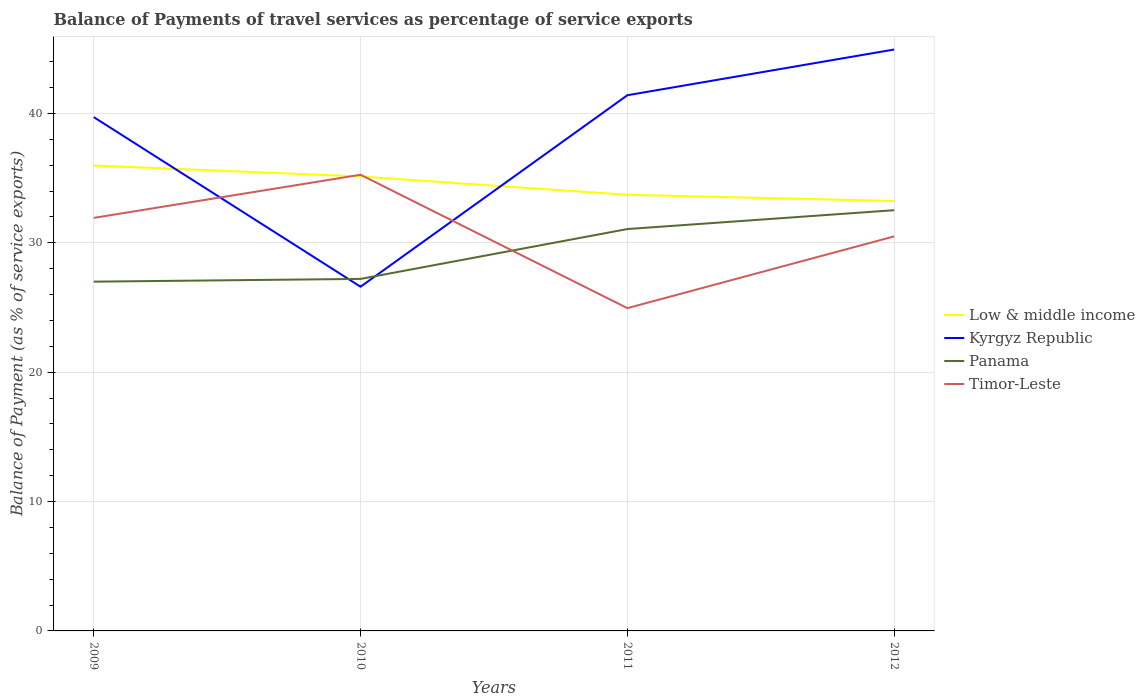Does the line corresponding to Timor-Leste intersect with the line corresponding to Panama?
Ensure brevity in your answer.  Yes. Is the number of lines equal to the number of legend labels?
Ensure brevity in your answer.  Yes. Across all years, what is the maximum balance of payments of travel services in Kyrgyz Republic?
Ensure brevity in your answer.  26.61. In which year was the balance of payments of travel services in Kyrgyz Republic maximum?
Make the answer very short. 2010. What is the total balance of payments of travel services in Panama in the graph?
Provide a short and direct response. -1.46. What is the difference between the highest and the second highest balance of payments of travel services in Timor-Leste?
Your answer should be compact. 10.31. What is the difference between the highest and the lowest balance of payments of travel services in Timor-Leste?
Your answer should be compact. 2. How many years are there in the graph?
Your response must be concise. 4. What is the difference between two consecutive major ticks on the Y-axis?
Your answer should be compact. 10. Does the graph contain any zero values?
Offer a terse response. No. Does the graph contain grids?
Offer a very short reply. Yes. Where does the legend appear in the graph?
Keep it short and to the point. Center right. How are the legend labels stacked?
Your answer should be very brief. Vertical. What is the title of the graph?
Ensure brevity in your answer.  Balance of Payments of travel services as percentage of service exports. What is the label or title of the X-axis?
Make the answer very short. Years. What is the label or title of the Y-axis?
Offer a terse response. Balance of Payment (as % of service exports). What is the Balance of Payment (as % of service exports) of Low & middle income in 2009?
Your answer should be compact. 35.98. What is the Balance of Payment (as % of service exports) in Kyrgyz Republic in 2009?
Ensure brevity in your answer.  39.72. What is the Balance of Payment (as % of service exports) in Panama in 2009?
Provide a short and direct response. 27. What is the Balance of Payment (as % of service exports) of Timor-Leste in 2009?
Provide a succinct answer. 31.93. What is the Balance of Payment (as % of service exports) of Low & middle income in 2010?
Offer a terse response. 35.13. What is the Balance of Payment (as % of service exports) in Kyrgyz Republic in 2010?
Make the answer very short. 26.61. What is the Balance of Payment (as % of service exports) in Panama in 2010?
Give a very brief answer. 27.21. What is the Balance of Payment (as % of service exports) in Timor-Leste in 2010?
Provide a succinct answer. 35.26. What is the Balance of Payment (as % of service exports) in Low & middle income in 2011?
Offer a very short reply. 33.71. What is the Balance of Payment (as % of service exports) in Kyrgyz Republic in 2011?
Provide a succinct answer. 41.41. What is the Balance of Payment (as % of service exports) in Panama in 2011?
Your answer should be compact. 31.06. What is the Balance of Payment (as % of service exports) in Timor-Leste in 2011?
Make the answer very short. 24.95. What is the Balance of Payment (as % of service exports) of Low & middle income in 2012?
Your response must be concise. 33.23. What is the Balance of Payment (as % of service exports) of Kyrgyz Republic in 2012?
Offer a very short reply. 44.94. What is the Balance of Payment (as % of service exports) in Panama in 2012?
Your answer should be very brief. 32.52. What is the Balance of Payment (as % of service exports) in Timor-Leste in 2012?
Your answer should be compact. 30.5. Across all years, what is the maximum Balance of Payment (as % of service exports) of Low & middle income?
Your answer should be compact. 35.98. Across all years, what is the maximum Balance of Payment (as % of service exports) of Kyrgyz Republic?
Make the answer very short. 44.94. Across all years, what is the maximum Balance of Payment (as % of service exports) in Panama?
Make the answer very short. 32.52. Across all years, what is the maximum Balance of Payment (as % of service exports) in Timor-Leste?
Provide a short and direct response. 35.26. Across all years, what is the minimum Balance of Payment (as % of service exports) in Low & middle income?
Give a very brief answer. 33.23. Across all years, what is the minimum Balance of Payment (as % of service exports) in Kyrgyz Republic?
Your response must be concise. 26.61. Across all years, what is the minimum Balance of Payment (as % of service exports) in Panama?
Keep it short and to the point. 27. Across all years, what is the minimum Balance of Payment (as % of service exports) in Timor-Leste?
Ensure brevity in your answer.  24.95. What is the total Balance of Payment (as % of service exports) in Low & middle income in the graph?
Your answer should be compact. 138.06. What is the total Balance of Payment (as % of service exports) of Kyrgyz Republic in the graph?
Keep it short and to the point. 152.68. What is the total Balance of Payment (as % of service exports) in Panama in the graph?
Give a very brief answer. 117.8. What is the total Balance of Payment (as % of service exports) of Timor-Leste in the graph?
Provide a succinct answer. 122.64. What is the difference between the Balance of Payment (as % of service exports) in Low & middle income in 2009 and that in 2010?
Ensure brevity in your answer.  0.85. What is the difference between the Balance of Payment (as % of service exports) in Kyrgyz Republic in 2009 and that in 2010?
Make the answer very short. 13.11. What is the difference between the Balance of Payment (as % of service exports) of Panama in 2009 and that in 2010?
Offer a very short reply. -0.21. What is the difference between the Balance of Payment (as % of service exports) in Timor-Leste in 2009 and that in 2010?
Make the answer very short. -3.33. What is the difference between the Balance of Payment (as % of service exports) in Low & middle income in 2009 and that in 2011?
Offer a terse response. 2.27. What is the difference between the Balance of Payment (as % of service exports) in Kyrgyz Republic in 2009 and that in 2011?
Provide a succinct answer. -1.69. What is the difference between the Balance of Payment (as % of service exports) of Panama in 2009 and that in 2011?
Offer a very short reply. -4.07. What is the difference between the Balance of Payment (as % of service exports) in Timor-Leste in 2009 and that in 2011?
Your answer should be very brief. 6.98. What is the difference between the Balance of Payment (as % of service exports) in Low & middle income in 2009 and that in 2012?
Give a very brief answer. 2.74. What is the difference between the Balance of Payment (as % of service exports) of Kyrgyz Republic in 2009 and that in 2012?
Your answer should be compact. -5.23. What is the difference between the Balance of Payment (as % of service exports) in Panama in 2009 and that in 2012?
Offer a very short reply. -5.52. What is the difference between the Balance of Payment (as % of service exports) in Timor-Leste in 2009 and that in 2012?
Your answer should be compact. 1.43. What is the difference between the Balance of Payment (as % of service exports) of Low & middle income in 2010 and that in 2011?
Offer a very short reply. 1.42. What is the difference between the Balance of Payment (as % of service exports) of Kyrgyz Republic in 2010 and that in 2011?
Provide a short and direct response. -14.8. What is the difference between the Balance of Payment (as % of service exports) in Panama in 2010 and that in 2011?
Make the answer very short. -3.85. What is the difference between the Balance of Payment (as % of service exports) in Timor-Leste in 2010 and that in 2011?
Your answer should be compact. 10.31. What is the difference between the Balance of Payment (as % of service exports) in Low & middle income in 2010 and that in 2012?
Offer a terse response. 1.9. What is the difference between the Balance of Payment (as % of service exports) in Kyrgyz Republic in 2010 and that in 2012?
Keep it short and to the point. -18.34. What is the difference between the Balance of Payment (as % of service exports) of Panama in 2010 and that in 2012?
Offer a terse response. -5.31. What is the difference between the Balance of Payment (as % of service exports) of Timor-Leste in 2010 and that in 2012?
Your answer should be compact. 4.76. What is the difference between the Balance of Payment (as % of service exports) in Low & middle income in 2011 and that in 2012?
Your answer should be very brief. 0.48. What is the difference between the Balance of Payment (as % of service exports) in Kyrgyz Republic in 2011 and that in 2012?
Ensure brevity in your answer.  -3.53. What is the difference between the Balance of Payment (as % of service exports) of Panama in 2011 and that in 2012?
Offer a terse response. -1.46. What is the difference between the Balance of Payment (as % of service exports) in Timor-Leste in 2011 and that in 2012?
Offer a very short reply. -5.55. What is the difference between the Balance of Payment (as % of service exports) of Low & middle income in 2009 and the Balance of Payment (as % of service exports) of Kyrgyz Republic in 2010?
Ensure brevity in your answer.  9.37. What is the difference between the Balance of Payment (as % of service exports) of Low & middle income in 2009 and the Balance of Payment (as % of service exports) of Panama in 2010?
Make the answer very short. 8.77. What is the difference between the Balance of Payment (as % of service exports) of Low & middle income in 2009 and the Balance of Payment (as % of service exports) of Timor-Leste in 2010?
Offer a very short reply. 0.72. What is the difference between the Balance of Payment (as % of service exports) of Kyrgyz Republic in 2009 and the Balance of Payment (as % of service exports) of Panama in 2010?
Ensure brevity in your answer.  12.51. What is the difference between the Balance of Payment (as % of service exports) in Kyrgyz Republic in 2009 and the Balance of Payment (as % of service exports) in Timor-Leste in 2010?
Ensure brevity in your answer.  4.46. What is the difference between the Balance of Payment (as % of service exports) of Panama in 2009 and the Balance of Payment (as % of service exports) of Timor-Leste in 2010?
Give a very brief answer. -8.26. What is the difference between the Balance of Payment (as % of service exports) of Low & middle income in 2009 and the Balance of Payment (as % of service exports) of Kyrgyz Republic in 2011?
Your response must be concise. -5.43. What is the difference between the Balance of Payment (as % of service exports) in Low & middle income in 2009 and the Balance of Payment (as % of service exports) in Panama in 2011?
Ensure brevity in your answer.  4.91. What is the difference between the Balance of Payment (as % of service exports) of Low & middle income in 2009 and the Balance of Payment (as % of service exports) of Timor-Leste in 2011?
Provide a short and direct response. 11.03. What is the difference between the Balance of Payment (as % of service exports) in Kyrgyz Republic in 2009 and the Balance of Payment (as % of service exports) in Panama in 2011?
Give a very brief answer. 8.65. What is the difference between the Balance of Payment (as % of service exports) of Kyrgyz Republic in 2009 and the Balance of Payment (as % of service exports) of Timor-Leste in 2011?
Your response must be concise. 14.77. What is the difference between the Balance of Payment (as % of service exports) in Panama in 2009 and the Balance of Payment (as % of service exports) in Timor-Leste in 2011?
Offer a very short reply. 2.05. What is the difference between the Balance of Payment (as % of service exports) in Low & middle income in 2009 and the Balance of Payment (as % of service exports) in Kyrgyz Republic in 2012?
Your answer should be compact. -8.97. What is the difference between the Balance of Payment (as % of service exports) of Low & middle income in 2009 and the Balance of Payment (as % of service exports) of Panama in 2012?
Give a very brief answer. 3.46. What is the difference between the Balance of Payment (as % of service exports) of Low & middle income in 2009 and the Balance of Payment (as % of service exports) of Timor-Leste in 2012?
Make the answer very short. 5.48. What is the difference between the Balance of Payment (as % of service exports) of Kyrgyz Republic in 2009 and the Balance of Payment (as % of service exports) of Panama in 2012?
Your answer should be very brief. 7.19. What is the difference between the Balance of Payment (as % of service exports) in Kyrgyz Republic in 2009 and the Balance of Payment (as % of service exports) in Timor-Leste in 2012?
Offer a very short reply. 9.22. What is the difference between the Balance of Payment (as % of service exports) in Panama in 2009 and the Balance of Payment (as % of service exports) in Timor-Leste in 2012?
Your answer should be compact. -3.5. What is the difference between the Balance of Payment (as % of service exports) in Low & middle income in 2010 and the Balance of Payment (as % of service exports) in Kyrgyz Republic in 2011?
Keep it short and to the point. -6.28. What is the difference between the Balance of Payment (as % of service exports) in Low & middle income in 2010 and the Balance of Payment (as % of service exports) in Panama in 2011?
Keep it short and to the point. 4.07. What is the difference between the Balance of Payment (as % of service exports) in Low & middle income in 2010 and the Balance of Payment (as % of service exports) in Timor-Leste in 2011?
Ensure brevity in your answer.  10.18. What is the difference between the Balance of Payment (as % of service exports) of Kyrgyz Republic in 2010 and the Balance of Payment (as % of service exports) of Panama in 2011?
Your answer should be very brief. -4.46. What is the difference between the Balance of Payment (as % of service exports) in Kyrgyz Republic in 2010 and the Balance of Payment (as % of service exports) in Timor-Leste in 2011?
Offer a very short reply. 1.66. What is the difference between the Balance of Payment (as % of service exports) in Panama in 2010 and the Balance of Payment (as % of service exports) in Timor-Leste in 2011?
Make the answer very short. 2.26. What is the difference between the Balance of Payment (as % of service exports) of Low & middle income in 2010 and the Balance of Payment (as % of service exports) of Kyrgyz Republic in 2012?
Your answer should be very brief. -9.81. What is the difference between the Balance of Payment (as % of service exports) in Low & middle income in 2010 and the Balance of Payment (as % of service exports) in Panama in 2012?
Your answer should be compact. 2.61. What is the difference between the Balance of Payment (as % of service exports) of Low & middle income in 2010 and the Balance of Payment (as % of service exports) of Timor-Leste in 2012?
Provide a short and direct response. 4.63. What is the difference between the Balance of Payment (as % of service exports) of Kyrgyz Republic in 2010 and the Balance of Payment (as % of service exports) of Panama in 2012?
Your answer should be very brief. -5.92. What is the difference between the Balance of Payment (as % of service exports) in Kyrgyz Republic in 2010 and the Balance of Payment (as % of service exports) in Timor-Leste in 2012?
Keep it short and to the point. -3.89. What is the difference between the Balance of Payment (as % of service exports) of Panama in 2010 and the Balance of Payment (as % of service exports) of Timor-Leste in 2012?
Your response must be concise. -3.29. What is the difference between the Balance of Payment (as % of service exports) of Low & middle income in 2011 and the Balance of Payment (as % of service exports) of Kyrgyz Republic in 2012?
Offer a very short reply. -11.23. What is the difference between the Balance of Payment (as % of service exports) in Low & middle income in 2011 and the Balance of Payment (as % of service exports) in Panama in 2012?
Your response must be concise. 1.19. What is the difference between the Balance of Payment (as % of service exports) in Low & middle income in 2011 and the Balance of Payment (as % of service exports) in Timor-Leste in 2012?
Your response must be concise. 3.21. What is the difference between the Balance of Payment (as % of service exports) in Kyrgyz Republic in 2011 and the Balance of Payment (as % of service exports) in Panama in 2012?
Your response must be concise. 8.89. What is the difference between the Balance of Payment (as % of service exports) in Kyrgyz Republic in 2011 and the Balance of Payment (as % of service exports) in Timor-Leste in 2012?
Provide a short and direct response. 10.91. What is the difference between the Balance of Payment (as % of service exports) of Panama in 2011 and the Balance of Payment (as % of service exports) of Timor-Leste in 2012?
Give a very brief answer. 0.57. What is the average Balance of Payment (as % of service exports) of Low & middle income per year?
Your answer should be compact. 34.51. What is the average Balance of Payment (as % of service exports) of Kyrgyz Republic per year?
Provide a short and direct response. 38.17. What is the average Balance of Payment (as % of service exports) in Panama per year?
Provide a short and direct response. 29.45. What is the average Balance of Payment (as % of service exports) in Timor-Leste per year?
Provide a short and direct response. 30.66. In the year 2009, what is the difference between the Balance of Payment (as % of service exports) of Low & middle income and Balance of Payment (as % of service exports) of Kyrgyz Republic?
Provide a succinct answer. -3.74. In the year 2009, what is the difference between the Balance of Payment (as % of service exports) of Low & middle income and Balance of Payment (as % of service exports) of Panama?
Offer a very short reply. 8.98. In the year 2009, what is the difference between the Balance of Payment (as % of service exports) in Low & middle income and Balance of Payment (as % of service exports) in Timor-Leste?
Offer a very short reply. 4.05. In the year 2009, what is the difference between the Balance of Payment (as % of service exports) of Kyrgyz Republic and Balance of Payment (as % of service exports) of Panama?
Provide a succinct answer. 12.72. In the year 2009, what is the difference between the Balance of Payment (as % of service exports) in Kyrgyz Republic and Balance of Payment (as % of service exports) in Timor-Leste?
Give a very brief answer. 7.79. In the year 2009, what is the difference between the Balance of Payment (as % of service exports) of Panama and Balance of Payment (as % of service exports) of Timor-Leste?
Your answer should be very brief. -4.93. In the year 2010, what is the difference between the Balance of Payment (as % of service exports) in Low & middle income and Balance of Payment (as % of service exports) in Kyrgyz Republic?
Your answer should be very brief. 8.52. In the year 2010, what is the difference between the Balance of Payment (as % of service exports) of Low & middle income and Balance of Payment (as % of service exports) of Panama?
Your answer should be compact. 7.92. In the year 2010, what is the difference between the Balance of Payment (as % of service exports) in Low & middle income and Balance of Payment (as % of service exports) in Timor-Leste?
Provide a succinct answer. -0.13. In the year 2010, what is the difference between the Balance of Payment (as % of service exports) in Kyrgyz Republic and Balance of Payment (as % of service exports) in Panama?
Offer a very short reply. -0.6. In the year 2010, what is the difference between the Balance of Payment (as % of service exports) in Kyrgyz Republic and Balance of Payment (as % of service exports) in Timor-Leste?
Your response must be concise. -8.65. In the year 2010, what is the difference between the Balance of Payment (as % of service exports) in Panama and Balance of Payment (as % of service exports) in Timor-Leste?
Give a very brief answer. -8.05. In the year 2011, what is the difference between the Balance of Payment (as % of service exports) in Low & middle income and Balance of Payment (as % of service exports) in Kyrgyz Republic?
Ensure brevity in your answer.  -7.7. In the year 2011, what is the difference between the Balance of Payment (as % of service exports) in Low & middle income and Balance of Payment (as % of service exports) in Panama?
Ensure brevity in your answer.  2.65. In the year 2011, what is the difference between the Balance of Payment (as % of service exports) in Low & middle income and Balance of Payment (as % of service exports) in Timor-Leste?
Make the answer very short. 8.76. In the year 2011, what is the difference between the Balance of Payment (as % of service exports) in Kyrgyz Republic and Balance of Payment (as % of service exports) in Panama?
Ensure brevity in your answer.  10.34. In the year 2011, what is the difference between the Balance of Payment (as % of service exports) in Kyrgyz Republic and Balance of Payment (as % of service exports) in Timor-Leste?
Offer a terse response. 16.46. In the year 2011, what is the difference between the Balance of Payment (as % of service exports) in Panama and Balance of Payment (as % of service exports) in Timor-Leste?
Your response must be concise. 6.11. In the year 2012, what is the difference between the Balance of Payment (as % of service exports) of Low & middle income and Balance of Payment (as % of service exports) of Kyrgyz Republic?
Keep it short and to the point. -11.71. In the year 2012, what is the difference between the Balance of Payment (as % of service exports) of Low & middle income and Balance of Payment (as % of service exports) of Panama?
Provide a succinct answer. 0.71. In the year 2012, what is the difference between the Balance of Payment (as % of service exports) in Low & middle income and Balance of Payment (as % of service exports) in Timor-Leste?
Offer a terse response. 2.74. In the year 2012, what is the difference between the Balance of Payment (as % of service exports) of Kyrgyz Republic and Balance of Payment (as % of service exports) of Panama?
Make the answer very short. 12.42. In the year 2012, what is the difference between the Balance of Payment (as % of service exports) of Kyrgyz Republic and Balance of Payment (as % of service exports) of Timor-Leste?
Offer a very short reply. 14.44. In the year 2012, what is the difference between the Balance of Payment (as % of service exports) in Panama and Balance of Payment (as % of service exports) in Timor-Leste?
Offer a terse response. 2.02. What is the ratio of the Balance of Payment (as % of service exports) in Low & middle income in 2009 to that in 2010?
Provide a short and direct response. 1.02. What is the ratio of the Balance of Payment (as % of service exports) in Kyrgyz Republic in 2009 to that in 2010?
Ensure brevity in your answer.  1.49. What is the ratio of the Balance of Payment (as % of service exports) in Panama in 2009 to that in 2010?
Offer a terse response. 0.99. What is the ratio of the Balance of Payment (as % of service exports) of Timor-Leste in 2009 to that in 2010?
Make the answer very short. 0.91. What is the ratio of the Balance of Payment (as % of service exports) of Low & middle income in 2009 to that in 2011?
Keep it short and to the point. 1.07. What is the ratio of the Balance of Payment (as % of service exports) in Kyrgyz Republic in 2009 to that in 2011?
Offer a very short reply. 0.96. What is the ratio of the Balance of Payment (as % of service exports) of Panama in 2009 to that in 2011?
Ensure brevity in your answer.  0.87. What is the ratio of the Balance of Payment (as % of service exports) in Timor-Leste in 2009 to that in 2011?
Offer a terse response. 1.28. What is the ratio of the Balance of Payment (as % of service exports) of Low & middle income in 2009 to that in 2012?
Provide a short and direct response. 1.08. What is the ratio of the Balance of Payment (as % of service exports) of Kyrgyz Republic in 2009 to that in 2012?
Make the answer very short. 0.88. What is the ratio of the Balance of Payment (as % of service exports) of Panama in 2009 to that in 2012?
Provide a succinct answer. 0.83. What is the ratio of the Balance of Payment (as % of service exports) of Timor-Leste in 2009 to that in 2012?
Give a very brief answer. 1.05. What is the ratio of the Balance of Payment (as % of service exports) in Low & middle income in 2010 to that in 2011?
Provide a succinct answer. 1.04. What is the ratio of the Balance of Payment (as % of service exports) of Kyrgyz Republic in 2010 to that in 2011?
Offer a very short reply. 0.64. What is the ratio of the Balance of Payment (as % of service exports) in Panama in 2010 to that in 2011?
Your answer should be very brief. 0.88. What is the ratio of the Balance of Payment (as % of service exports) in Timor-Leste in 2010 to that in 2011?
Ensure brevity in your answer.  1.41. What is the ratio of the Balance of Payment (as % of service exports) in Low & middle income in 2010 to that in 2012?
Give a very brief answer. 1.06. What is the ratio of the Balance of Payment (as % of service exports) of Kyrgyz Republic in 2010 to that in 2012?
Give a very brief answer. 0.59. What is the ratio of the Balance of Payment (as % of service exports) in Panama in 2010 to that in 2012?
Ensure brevity in your answer.  0.84. What is the ratio of the Balance of Payment (as % of service exports) in Timor-Leste in 2010 to that in 2012?
Your answer should be very brief. 1.16. What is the ratio of the Balance of Payment (as % of service exports) in Low & middle income in 2011 to that in 2012?
Offer a terse response. 1.01. What is the ratio of the Balance of Payment (as % of service exports) of Kyrgyz Republic in 2011 to that in 2012?
Your answer should be compact. 0.92. What is the ratio of the Balance of Payment (as % of service exports) of Panama in 2011 to that in 2012?
Keep it short and to the point. 0.96. What is the ratio of the Balance of Payment (as % of service exports) in Timor-Leste in 2011 to that in 2012?
Your answer should be compact. 0.82. What is the difference between the highest and the second highest Balance of Payment (as % of service exports) in Low & middle income?
Provide a succinct answer. 0.85. What is the difference between the highest and the second highest Balance of Payment (as % of service exports) of Kyrgyz Republic?
Your response must be concise. 3.53. What is the difference between the highest and the second highest Balance of Payment (as % of service exports) in Panama?
Ensure brevity in your answer.  1.46. What is the difference between the highest and the second highest Balance of Payment (as % of service exports) in Timor-Leste?
Provide a succinct answer. 3.33. What is the difference between the highest and the lowest Balance of Payment (as % of service exports) of Low & middle income?
Offer a very short reply. 2.74. What is the difference between the highest and the lowest Balance of Payment (as % of service exports) in Kyrgyz Republic?
Your response must be concise. 18.34. What is the difference between the highest and the lowest Balance of Payment (as % of service exports) of Panama?
Your answer should be compact. 5.52. What is the difference between the highest and the lowest Balance of Payment (as % of service exports) in Timor-Leste?
Make the answer very short. 10.31. 